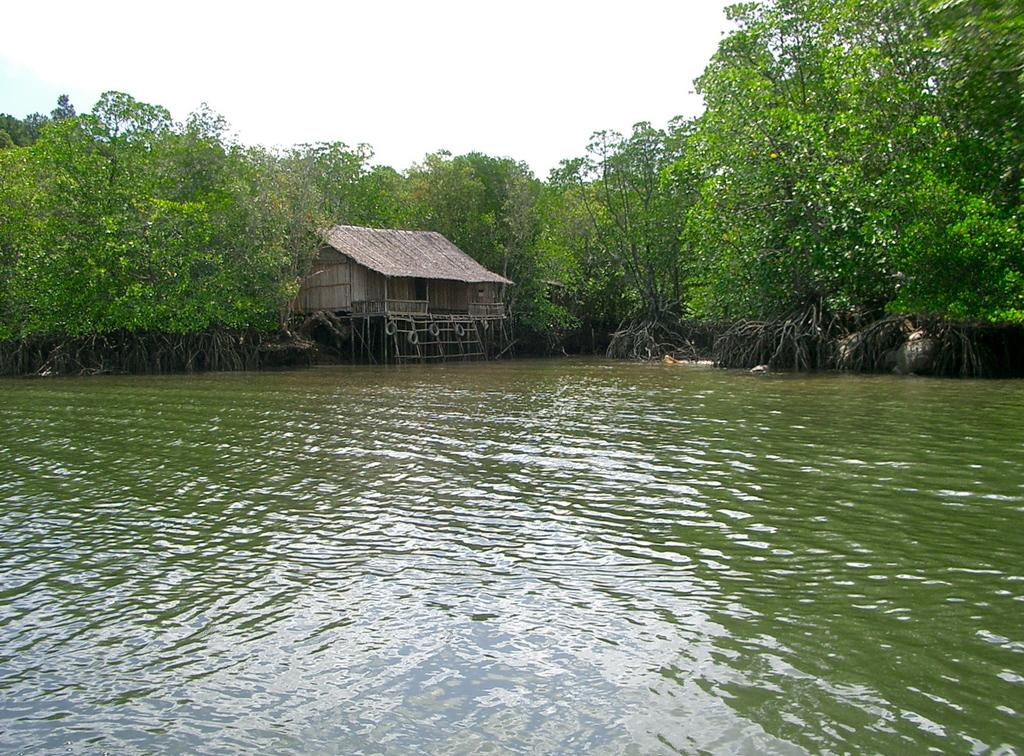What type of structure is in the image? There is a hut in the image. What is in front of the hut? There is water in front of the hut. What is behind the hut? There are trees behind the hut. What can be seen above the hut and trees? The sky is visible in the image. Can you see any pets in the image? There is no pet visible in the image. Is there any indication of rain in the image? There is no indication of rain in the image; the sky appears clear. 